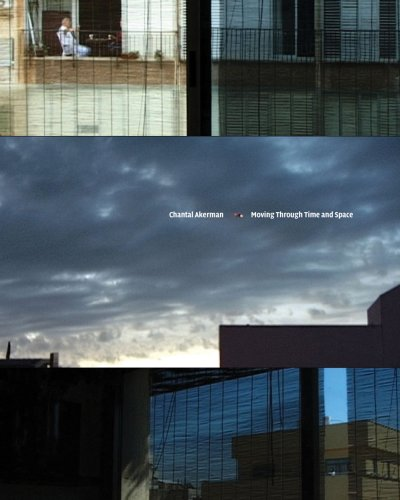Who is the author of this book? The author of 'Chantal Akerman: Moving Through Time and Space' is Terrie Sultan, an established figure in the art world known for her insightful writings on contemporary artists. 